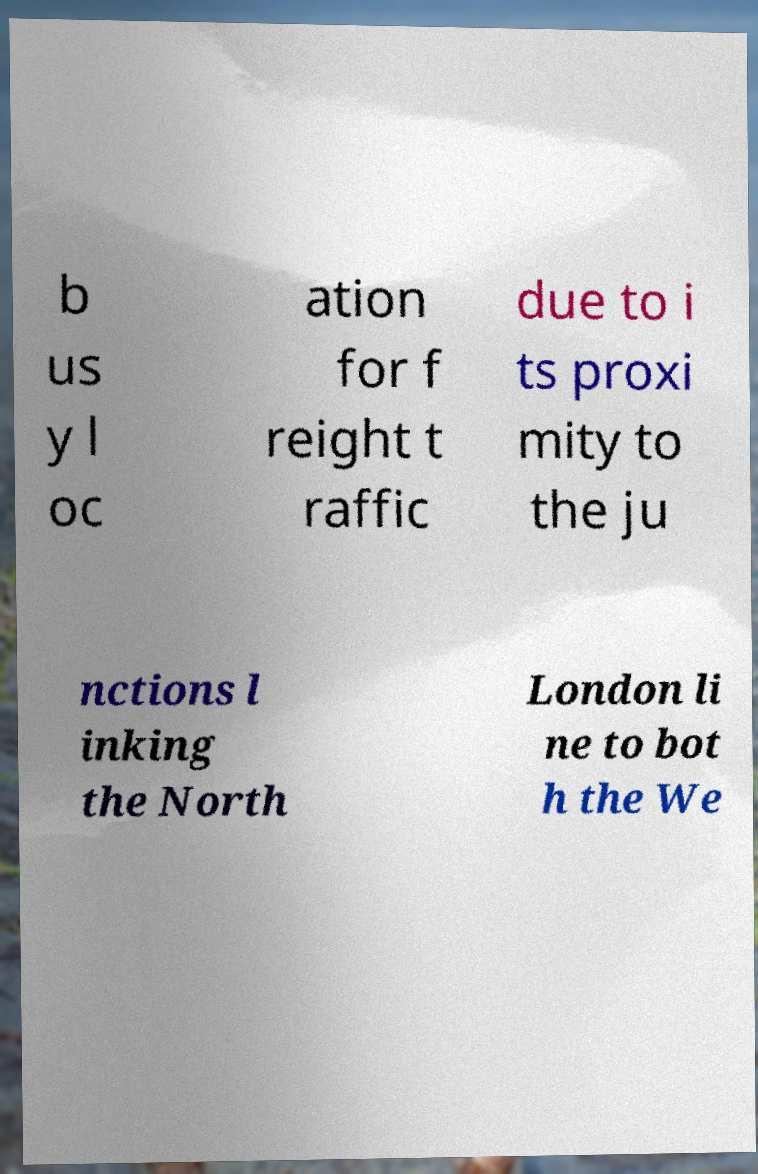Can you accurately transcribe the text from the provided image for me? b us y l oc ation for f reight t raffic due to i ts proxi mity to the ju nctions l inking the North London li ne to bot h the We 